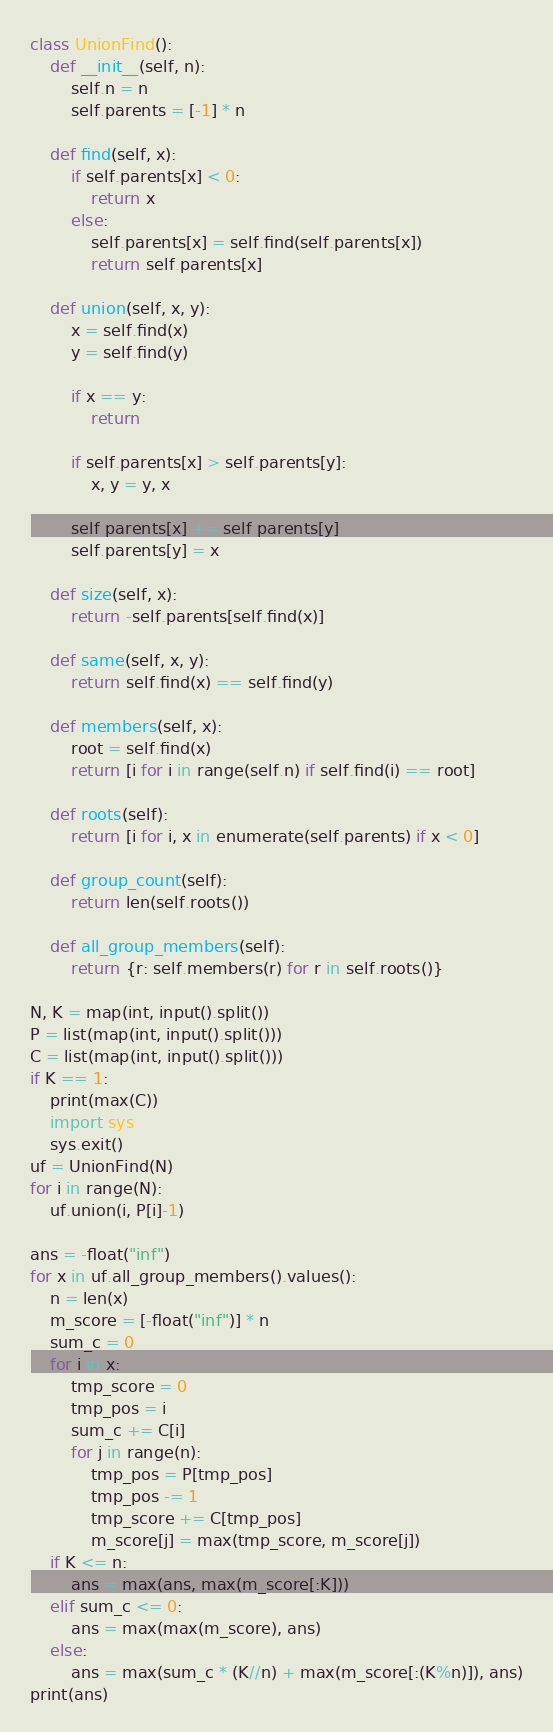Convert code to text. <code><loc_0><loc_0><loc_500><loc_500><_Python_>class UnionFind():
    def __init__(self, n):
        self.n = n
        self.parents = [-1] * n

    def find(self, x):
        if self.parents[x] < 0:
            return x
        else:
            self.parents[x] = self.find(self.parents[x])
            return self.parents[x]

    def union(self, x, y):
        x = self.find(x)
        y = self.find(y)

        if x == y:
            return

        if self.parents[x] > self.parents[y]:
            x, y = y, x

        self.parents[x] += self.parents[y]
        self.parents[y] = x

    def size(self, x):
        return -self.parents[self.find(x)]

    def same(self, x, y):
        return self.find(x) == self.find(y)

    def members(self, x):
        root = self.find(x)
        return [i for i in range(self.n) if self.find(i) == root]

    def roots(self):
        return [i for i, x in enumerate(self.parents) if x < 0]

    def group_count(self):
        return len(self.roots())

    def all_group_members(self):
        return {r: self.members(r) for r in self.roots()}

N, K = map(int, input().split())
P = list(map(int, input().split()))
C = list(map(int, input().split()))
if K == 1:
    print(max(C))
    import sys
    sys.exit()
uf = UnionFind(N)
for i in range(N):
    uf.union(i, P[i]-1)

ans = -float("inf")
for x in uf.all_group_members().values():
    n = len(x)
    m_score = [-float("inf")] * n
    sum_c = 0
    for i in x:
        tmp_score = 0
        tmp_pos = i
        sum_c += C[i]
        for j in range(n):
            tmp_pos = P[tmp_pos]
            tmp_pos -= 1
            tmp_score += C[tmp_pos]
            m_score[j] = max(tmp_score, m_score[j])
    if K <= n:
        ans = max(ans, max(m_score[:K]))
    elif sum_c <= 0:
        ans = max(max(m_score), ans)
    else:
        ans = max(sum_c * (K//n) + max(m_score[:(K%n)]), ans)
print(ans)</code> 